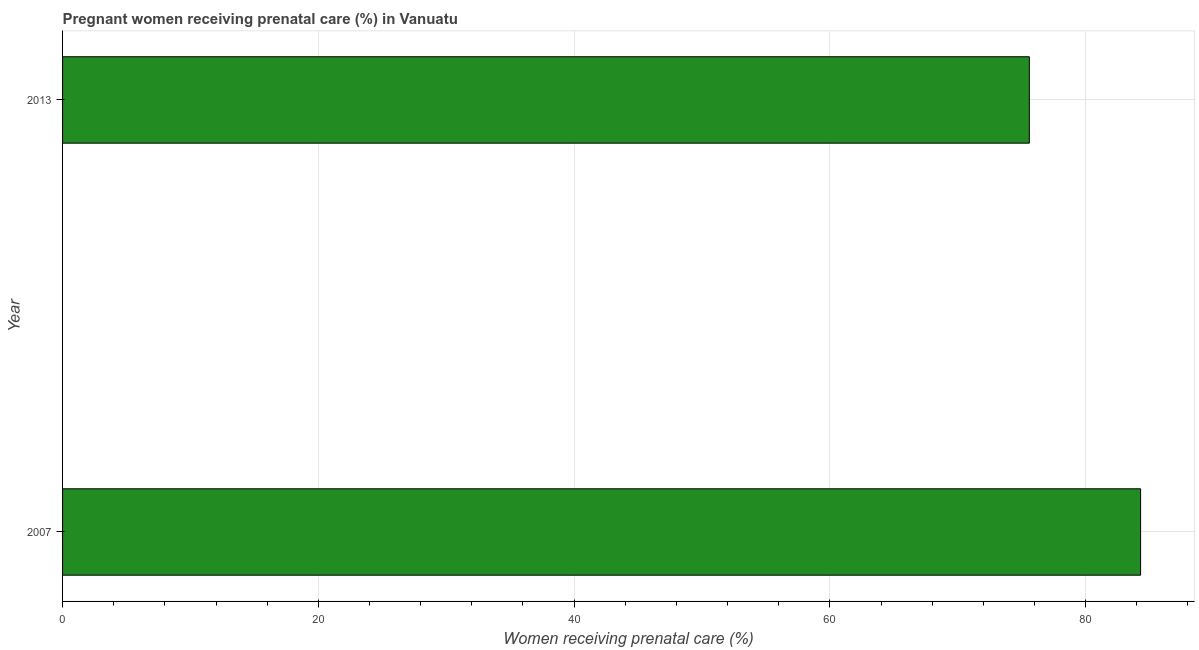What is the title of the graph?
Provide a short and direct response. Pregnant women receiving prenatal care (%) in Vanuatu. What is the label or title of the X-axis?
Offer a terse response. Women receiving prenatal care (%). What is the percentage of pregnant women receiving prenatal care in 2007?
Keep it short and to the point. 84.3. Across all years, what is the maximum percentage of pregnant women receiving prenatal care?
Your response must be concise. 84.3. Across all years, what is the minimum percentage of pregnant women receiving prenatal care?
Your answer should be very brief. 75.6. In which year was the percentage of pregnant women receiving prenatal care maximum?
Provide a succinct answer. 2007. What is the sum of the percentage of pregnant women receiving prenatal care?
Offer a very short reply. 159.9. What is the average percentage of pregnant women receiving prenatal care per year?
Offer a very short reply. 79.95. What is the median percentage of pregnant women receiving prenatal care?
Your response must be concise. 79.95. In how many years, is the percentage of pregnant women receiving prenatal care greater than 16 %?
Ensure brevity in your answer.  2. Do a majority of the years between 2007 and 2013 (inclusive) have percentage of pregnant women receiving prenatal care greater than 36 %?
Give a very brief answer. Yes. What is the ratio of the percentage of pregnant women receiving prenatal care in 2007 to that in 2013?
Keep it short and to the point. 1.11. Is the percentage of pregnant women receiving prenatal care in 2007 less than that in 2013?
Offer a terse response. No. How many bars are there?
Your answer should be compact. 2. Are all the bars in the graph horizontal?
Provide a short and direct response. Yes. How many years are there in the graph?
Offer a terse response. 2. Are the values on the major ticks of X-axis written in scientific E-notation?
Give a very brief answer. No. What is the Women receiving prenatal care (%) in 2007?
Your response must be concise. 84.3. What is the Women receiving prenatal care (%) of 2013?
Ensure brevity in your answer.  75.6. What is the difference between the Women receiving prenatal care (%) in 2007 and 2013?
Offer a terse response. 8.7. What is the ratio of the Women receiving prenatal care (%) in 2007 to that in 2013?
Your answer should be compact. 1.11. 